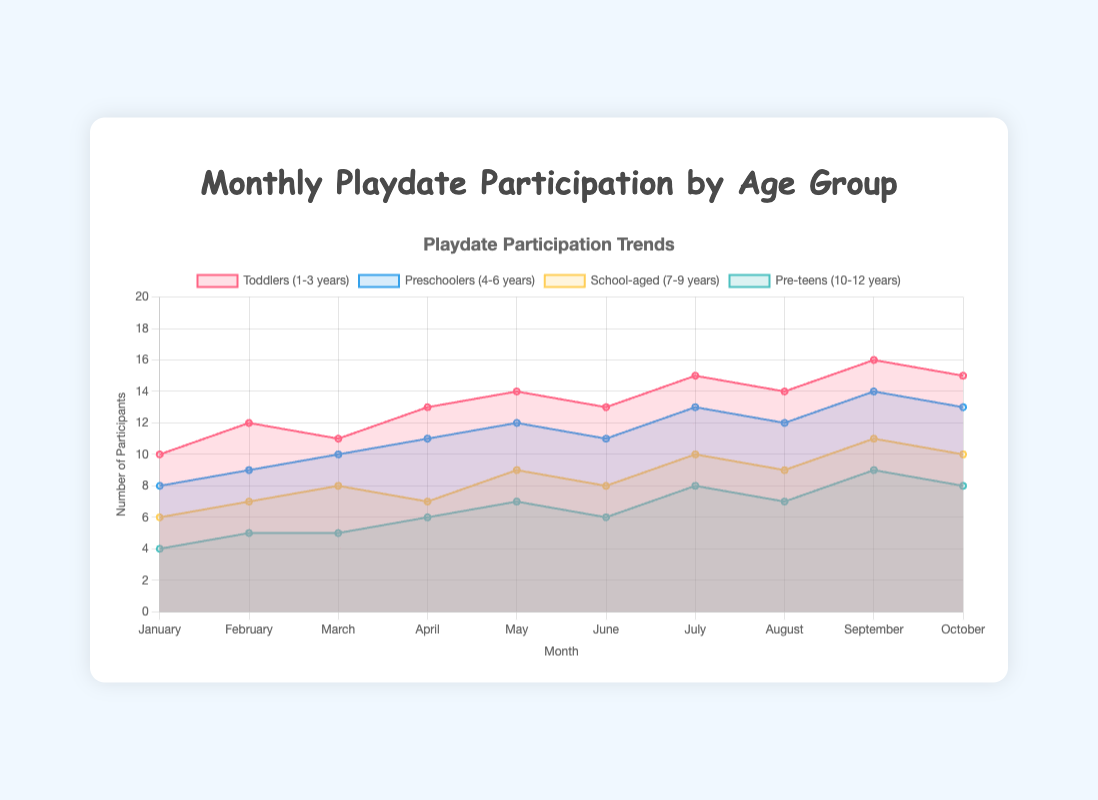How many different age groups are represented in the chart? The chart shows data for each age group, so we can count the different legends/labels in the chart. The age groups are "Toddlers (1-3 years)", "Preschoolers (4-6 years)", "School-aged (7-9 years)", and "Pre-teens (10-12 years)".
Answer: 4 What is the title of the chart? The title of the chart is usually displayed at the top. In this case, the title is "Monthly Playdate Participation by Age Group".
Answer: Monthly Playdate Participation by Age Group During which month did the "Preschoolers (4-6 years)" group have the highest participation? By examining the area corresponding to the "Preschoolers (4-6 years)" dataset, the highest value can be found by looking at the peak of this area. This occurs in September with 14 participants.
Answer: September Which age group had the lowest participation in March? To find the lowest participation in March, one needs to compare the March value of all age groups. "Pre-teens (10-12 years)" had the lowest value with 5 participants.
Answer: Pre-teens (10-12 years) What is the general trend for the "School-aged (7-9 years)" group over the months? Observing the line for "School-aged (7-9 years)" over the months shows an upward trend. Their participation starts at 6 participants in January and increases to 10 participants by October.
Answer: Increasing What is the total participation for "Toddlers (1-3 years)" in the first three months? Sum the participation values for January, February, and March for "Toddlers (1-3 years)": 10 (January) + 12 (February) + 11 (March) = 33.
Answer: 33 How many age groups had more than 10 participants in August? Check each age group's data for August. "Toddlers (1-3 years)" and "Preschoolers (4-6 years)" had more than 10 participants in August (14 and 12 respectively). Therefore, 2 age groups had more than 10 participants.
Answer: 2 Which month shows the highest aggregate participation across all age groups? Sum the participants for each month across all age groups and compare:
- January: 10 + 8 + 6 + 4 = 28
- February: 12 + 9 + 7 + 5 = 33
- March: 11 + 10 + 8 + 5 = 34
- April: 13 + 11 + 7 + 6 = 37
- May: 14 + 12 + 9 + 7 = 42
- June: 13 + 11 + 8 + 6 = 38
- July: 15 + 13 + 10 + 8 = 46
- August: 14 + 12 + 9 + 7 = 42
- September: 16 + 14 + 11 + 9 = 50
- October: 15 + 13 + 10 + 8 = 46
Therefore, September has the highest total with 50 participants.
Answer: September How does the participation trend of "Pre-teens (10-12 years)" compare to "Toddlers (1-3 years)"? Look at both age groups over time:
- "Toddlers (1-3 years)" have a steady increase from 10 to 15 participants.
- "Pre-teens (10-12 years)" also rise steadily but start from a lower initial value from 4 to 8 participants.
Both show increasing trends, but "Toddlers" start and end at higher values.
Answer: Both are increasing, but "Toddlers (1-3 years)" have higher values throughout What is the difference in participation between "Preschoolers (4-6 years)" and "School-aged (7-9 years)" in May? Subtract the values for May:
- "Preschoolers (4-6 years)": 12
- "School-aged (7-9 years)": 9
Difference = 12 - 9 = 3.
Answer: 3 